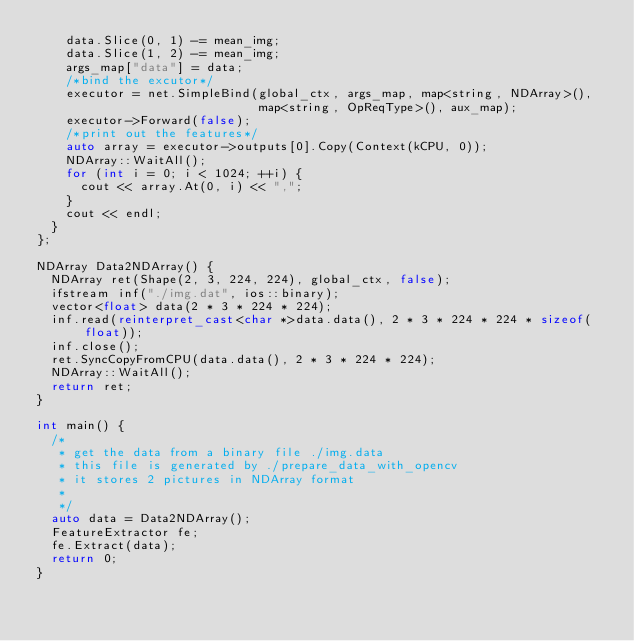<code> <loc_0><loc_0><loc_500><loc_500><_C++_>    data.Slice(0, 1) -= mean_img;
    data.Slice(1, 2) -= mean_img;
    args_map["data"] = data;
    /*bind the excutor*/
    executor = net.SimpleBind(global_ctx, args_map, map<string, NDArray>(),
                              map<string, OpReqType>(), aux_map);
    executor->Forward(false);
    /*print out the features*/
    auto array = executor->outputs[0].Copy(Context(kCPU, 0));
    NDArray::WaitAll();
    for (int i = 0; i < 1024; ++i) {
      cout << array.At(0, i) << ",";
    }
    cout << endl;
  }
};

NDArray Data2NDArray() {
  NDArray ret(Shape(2, 3, 224, 224), global_ctx, false);
  ifstream inf("./img.dat", ios::binary);
  vector<float> data(2 * 3 * 224 * 224);
  inf.read(reinterpret_cast<char *>data.data(), 2 * 3 * 224 * 224 * sizeof(float));
  inf.close();
  ret.SyncCopyFromCPU(data.data(), 2 * 3 * 224 * 224);
  NDArray::WaitAll();
  return ret;
}

int main() {
  /*
   * get the data from a binary file ./img.data
   * this file is generated by ./prepare_data_with_opencv
   * it stores 2 pictures in NDArray format
   *
   */
  auto data = Data2NDArray();
  FeatureExtractor fe;
  fe.Extract(data);
  return 0;
}
</code> 